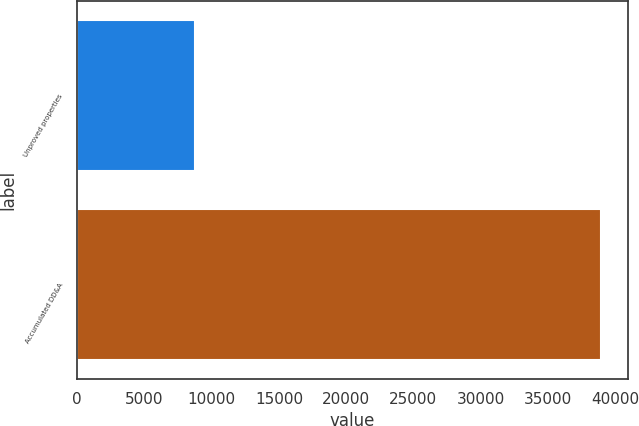Convert chart. <chart><loc_0><loc_0><loc_500><loc_500><bar_chart><fcel>Unproved properties<fcel>Accumulated DD&A<nl><fcel>8754<fcel>38978<nl></chart> 